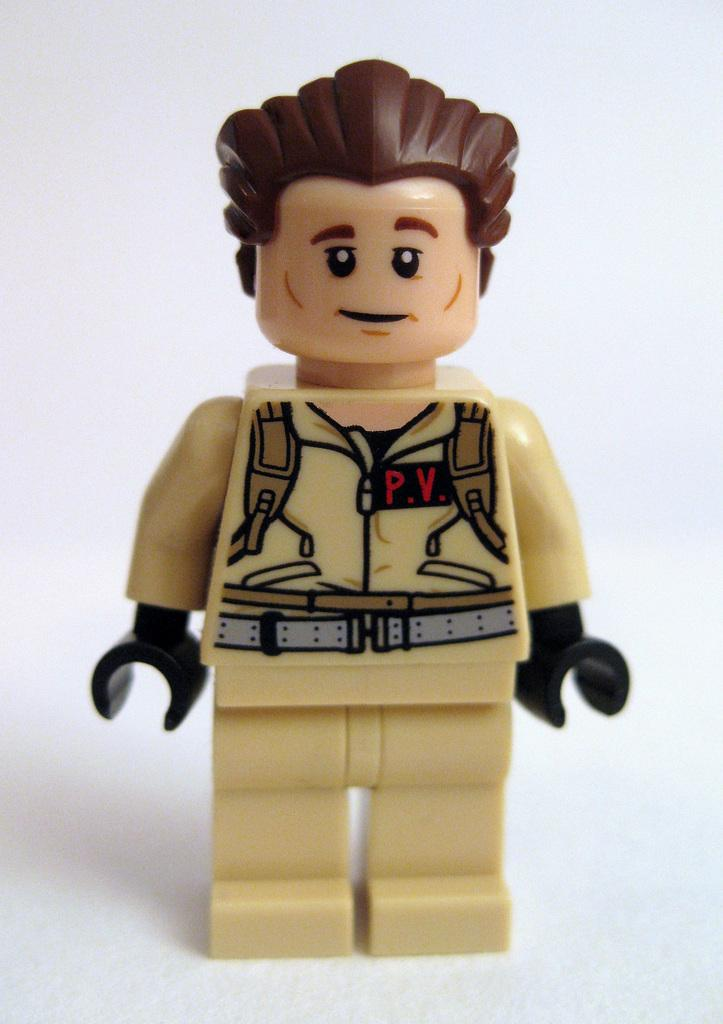What is the main subject of the image? There is a doll in the image. What material is the doll made of? The doll is made of plastic. What does the doll resemble? The doll looks like a policeman. What type of shade does the doll provide in the image? There is no shade provided by the doll in the image, as it is a plastic doll resembling a policeman. 